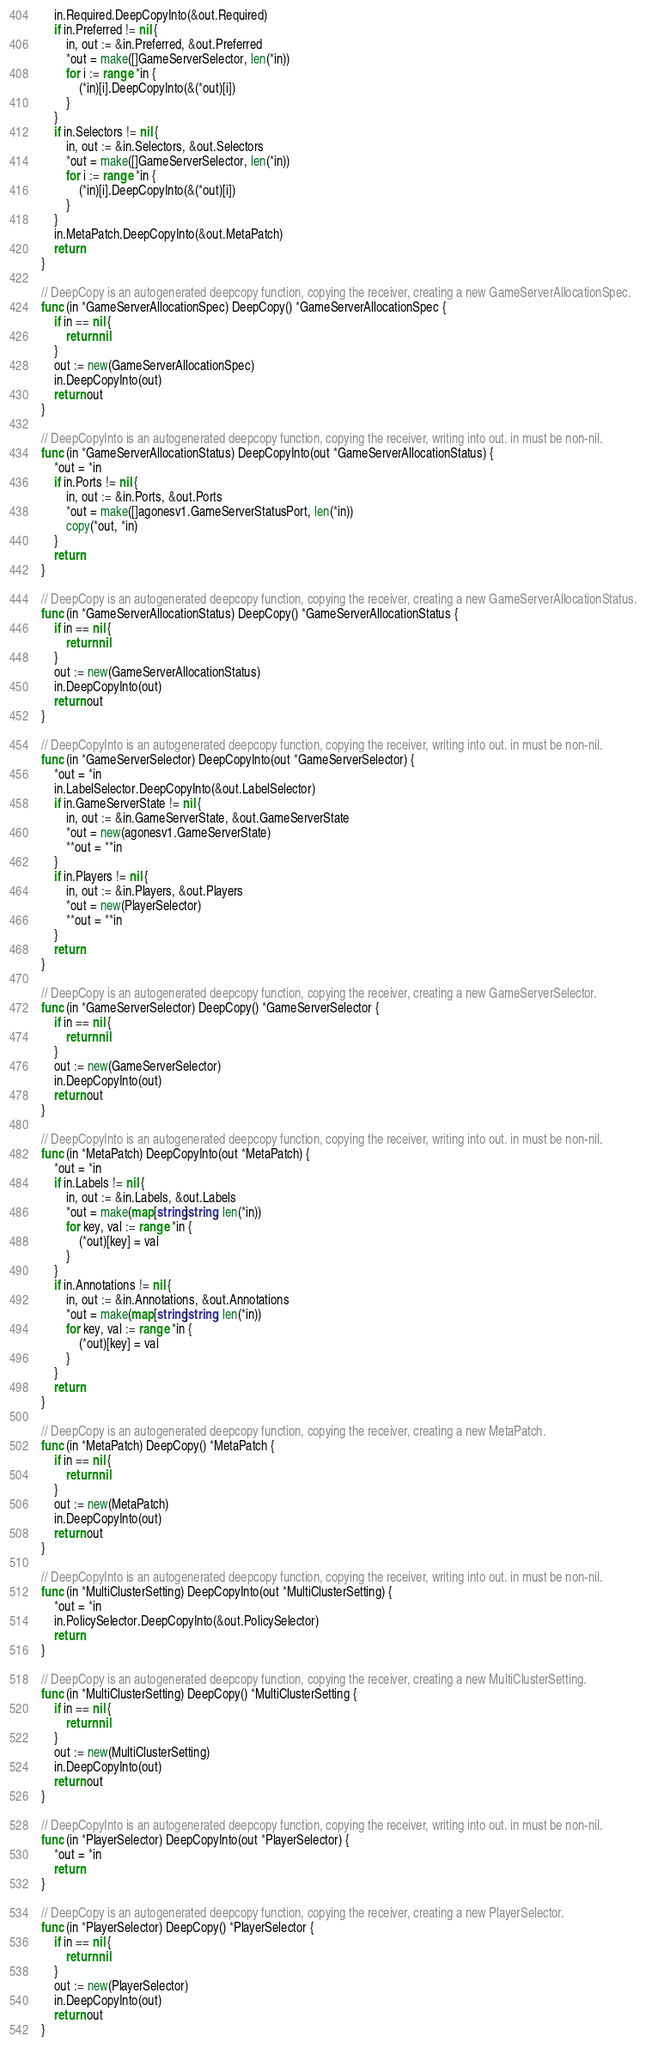Convert code to text. <code><loc_0><loc_0><loc_500><loc_500><_Go_>	in.Required.DeepCopyInto(&out.Required)
	if in.Preferred != nil {
		in, out := &in.Preferred, &out.Preferred
		*out = make([]GameServerSelector, len(*in))
		for i := range *in {
			(*in)[i].DeepCopyInto(&(*out)[i])
		}
	}
	if in.Selectors != nil {
		in, out := &in.Selectors, &out.Selectors
		*out = make([]GameServerSelector, len(*in))
		for i := range *in {
			(*in)[i].DeepCopyInto(&(*out)[i])
		}
	}
	in.MetaPatch.DeepCopyInto(&out.MetaPatch)
	return
}

// DeepCopy is an autogenerated deepcopy function, copying the receiver, creating a new GameServerAllocationSpec.
func (in *GameServerAllocationSpec) DeepCopy() *GameServerAllocationSpec {
	if in == nil {
		return nil
	}
	out := new(GameServerAllocationSpec)
	in.DeepCopyInto(out)
	return out
}

// DeepCopyInto is an autogenerated deepcopy function, copying the receiver, writing into out. in must be non-nil.
func (in *GameServerAllocationStatus) DeepCopyInto(out *GameServerAllocationStatus) {
	*out = *in
	if in.Ports != nil {
		in, out := &in.Ports, &out.Ports
		*out = make([]agonesv1.GameServerStatusPort, len(*in))
		copy(*out, *in)
	}
	return
}

// DeepCopy is an autogenerated deepcopy function, copying the receiver, creating a new GameServerAllocationStatus.
func (in *GameServerAllocationStatus) DeepCopy() *GameServerAllocationStatus {
	if in == nil {
		return nil
	}
	out := new(GameServerAllocationStatus)
	in.DeepCopyInto(out)
	return out
}

// DeepCopyInto is an autogenerated deepcopy function, copying the receiver, writing into out. in must be non-nil.
func (in *GameServerSelector) DeepCopyInto(out *GameServerSelector) {
	*out = *in
	in.LabelSelector.DeepCopyInto(&out.LabelSelector)
	if in.GameServerState != nil {
		in, out := &in.GameServerState, &out.GameServerState
		*out = new(agonesv1.GameServerState)
		**out = **in
	}
	if in.Players != nil {
		in, out := &in.Players, &out.Players
		*out = new(PlayerSelector)
		**out = **in
	}
	return
}

// DeepCopy is an autogenerated deepcopy function, copying the receiver, creating a new GameServerSelector.
func (in *GameServerSelector) DeepCopy() *GameServerSelector {
	if in == nil {
		return nil
	}
	out := new(GameServerSelector)
	in.DeepCopyInto(out)
	return out
}

// DeepCopyInto is an autogenerated deepcopy function, copying the receiver, writing into out. in must be non-nil.
func (in *MetaPatch) DeepCopyInto(out *MetaPatch) {
	*out = *in
	if in.Labels != nil {
		in, out := &in.Labels, &out.Labels
		*out = make(map[string]string, len(*in))
		for key, val := range *in {
			(*out)[key] = val
		}
	}
	if in.Annotations != nil {
		in, out := &in.Annotations, &out.Annotations
		*out = make(map[string]string, len(*in))
		for key, val := range *in {
			(*out)[key] = val
		}
	}
	return
}

// DeepCopy is an autogenerated deepcopy function, copying the receiver, creating a new MetaPatch.
func (in *MetaPatch) DeepCopy() *MetaPatch {
	if in == nil {
		return nil
	}
	out := new(MetaPatch)
	in.DeepCopyInto(out)
	return out
}

// DeepCopyInto is an autogenerated deepcopy function, copying the receiver, writing into out. in must be non-nil.
func (in *MultiClusterSetting) DeepCopyInto(out *MultiClusterSetting) {
	*out = *in
	in.PolicySelector.DeepCopyInto(&out.PolicySelector)
	return
}

// DeepCopy is an autogenerated deepcopy function, copying the receiver, creating a new MultiClusterSetting.
func (in *MultiClusterSetting) DeepCopy() *MultiClusterSetting {
	if in == nil {
		return nil
	}
	out := new(MultiClusterSetting)
	in.DeepCopyInto(out)
	return out
}

// DeepCopyInto is an autogenerated deepcopy function, copying the receiver, writing into out. in must be non-nil.
func (in *PlayerSelector) DeepCopyInto(out *PlayerSelector) {
	*out = *in
	return
}

// DeepCopy is an autogenerated deepcopy function, copying the receiver, creating a new PlayerSelector.
func (in *PlayerSelector) DeepCopy() *PlayerSelector {
	if in == nil {
		return nil
	}
	out := new(PlayerSelector)
	in.DeepCopyInto(out)
	return out
}
</code> 